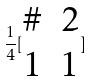<formula> <loc_0><loc_0><loc_500><loc_500>\frac { 1 } { 4 } [ \begin{matrix} \# & 2 \\ 1 & 1 \end{matrix} ]</formula> 